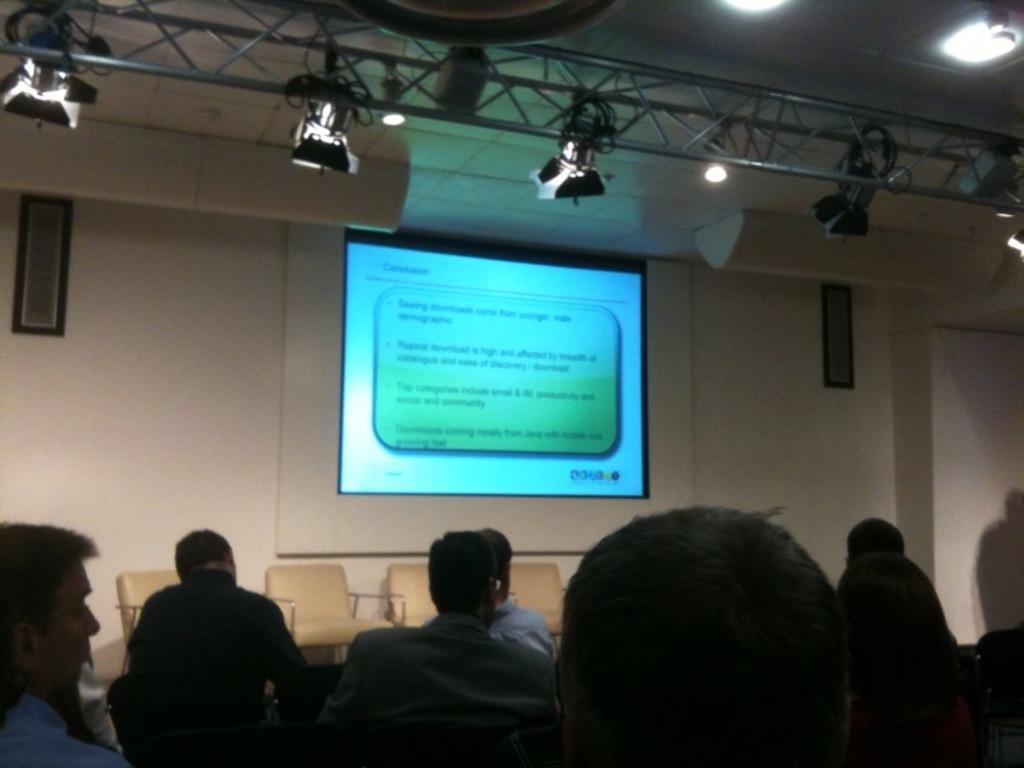What are the people in the image doing? The people in the image are sitting on chairs. What is on the wall in the image? There is a projector screen on the wall. What can be seen on the ceiling of the room? There are lightings on the top of the room. How are the chairs arranged in the image? The chairs are kept on the floor. What scent is being emitted from the yak in the image? There is no yak present in the image, so it cannot be emitting any scent. 